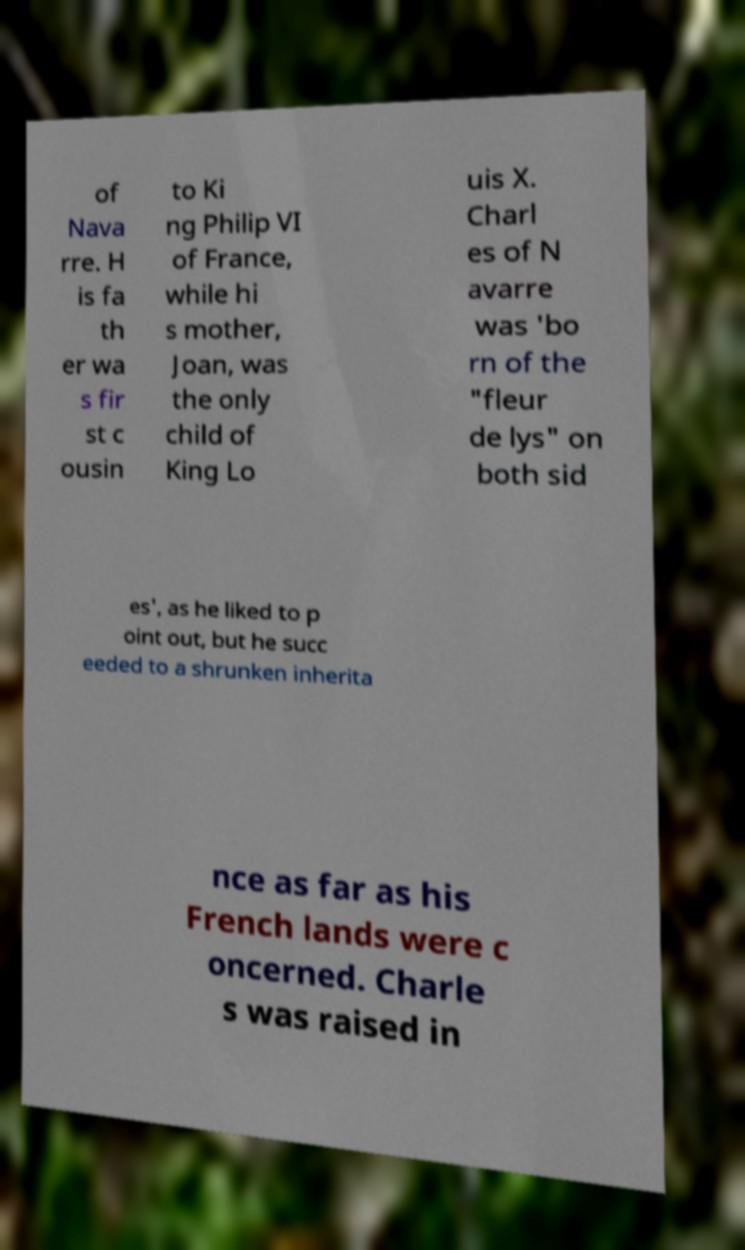Can you accurately transcribe the text from the provided image for me? of Nava rre. H is fa th er wa s fir st c ousin to Ki ng Philip VI of France, while hi s mother, Joan, was the only child of King Lo uis X. Charl es of N avarre was 'bo rn of the "fleur de lys" on both sid es', as he liked to p oint out, but he succ eeded to a shrunken inherita nce as far as his French lands were c oncerned. Charle s was raised in 